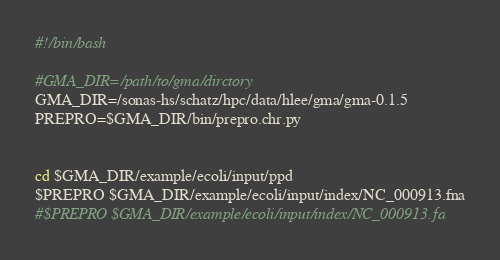Convert code to text. <code><loc_0><loc_0><loc_500><loc_500><_Bash_>#!/bin/bash 

#GMA_DIR=/path/to/gma/dirctory
GMA_DIR=/sonas-hs/schatz/hpc/data/hlee/gma/gma-0.1.5
PREPRO=$GMA_DIR/bin/prepro.chr.py


cd $GMA_DIR/example/ecoli/input/ppd 
$PREPRO $GMA_DIR/example/ecoli/input/index/NC_000913.fna
#$PREPRO $GMA_DIR/example/ecoli/input/index/NC_000913.fa



</code> 